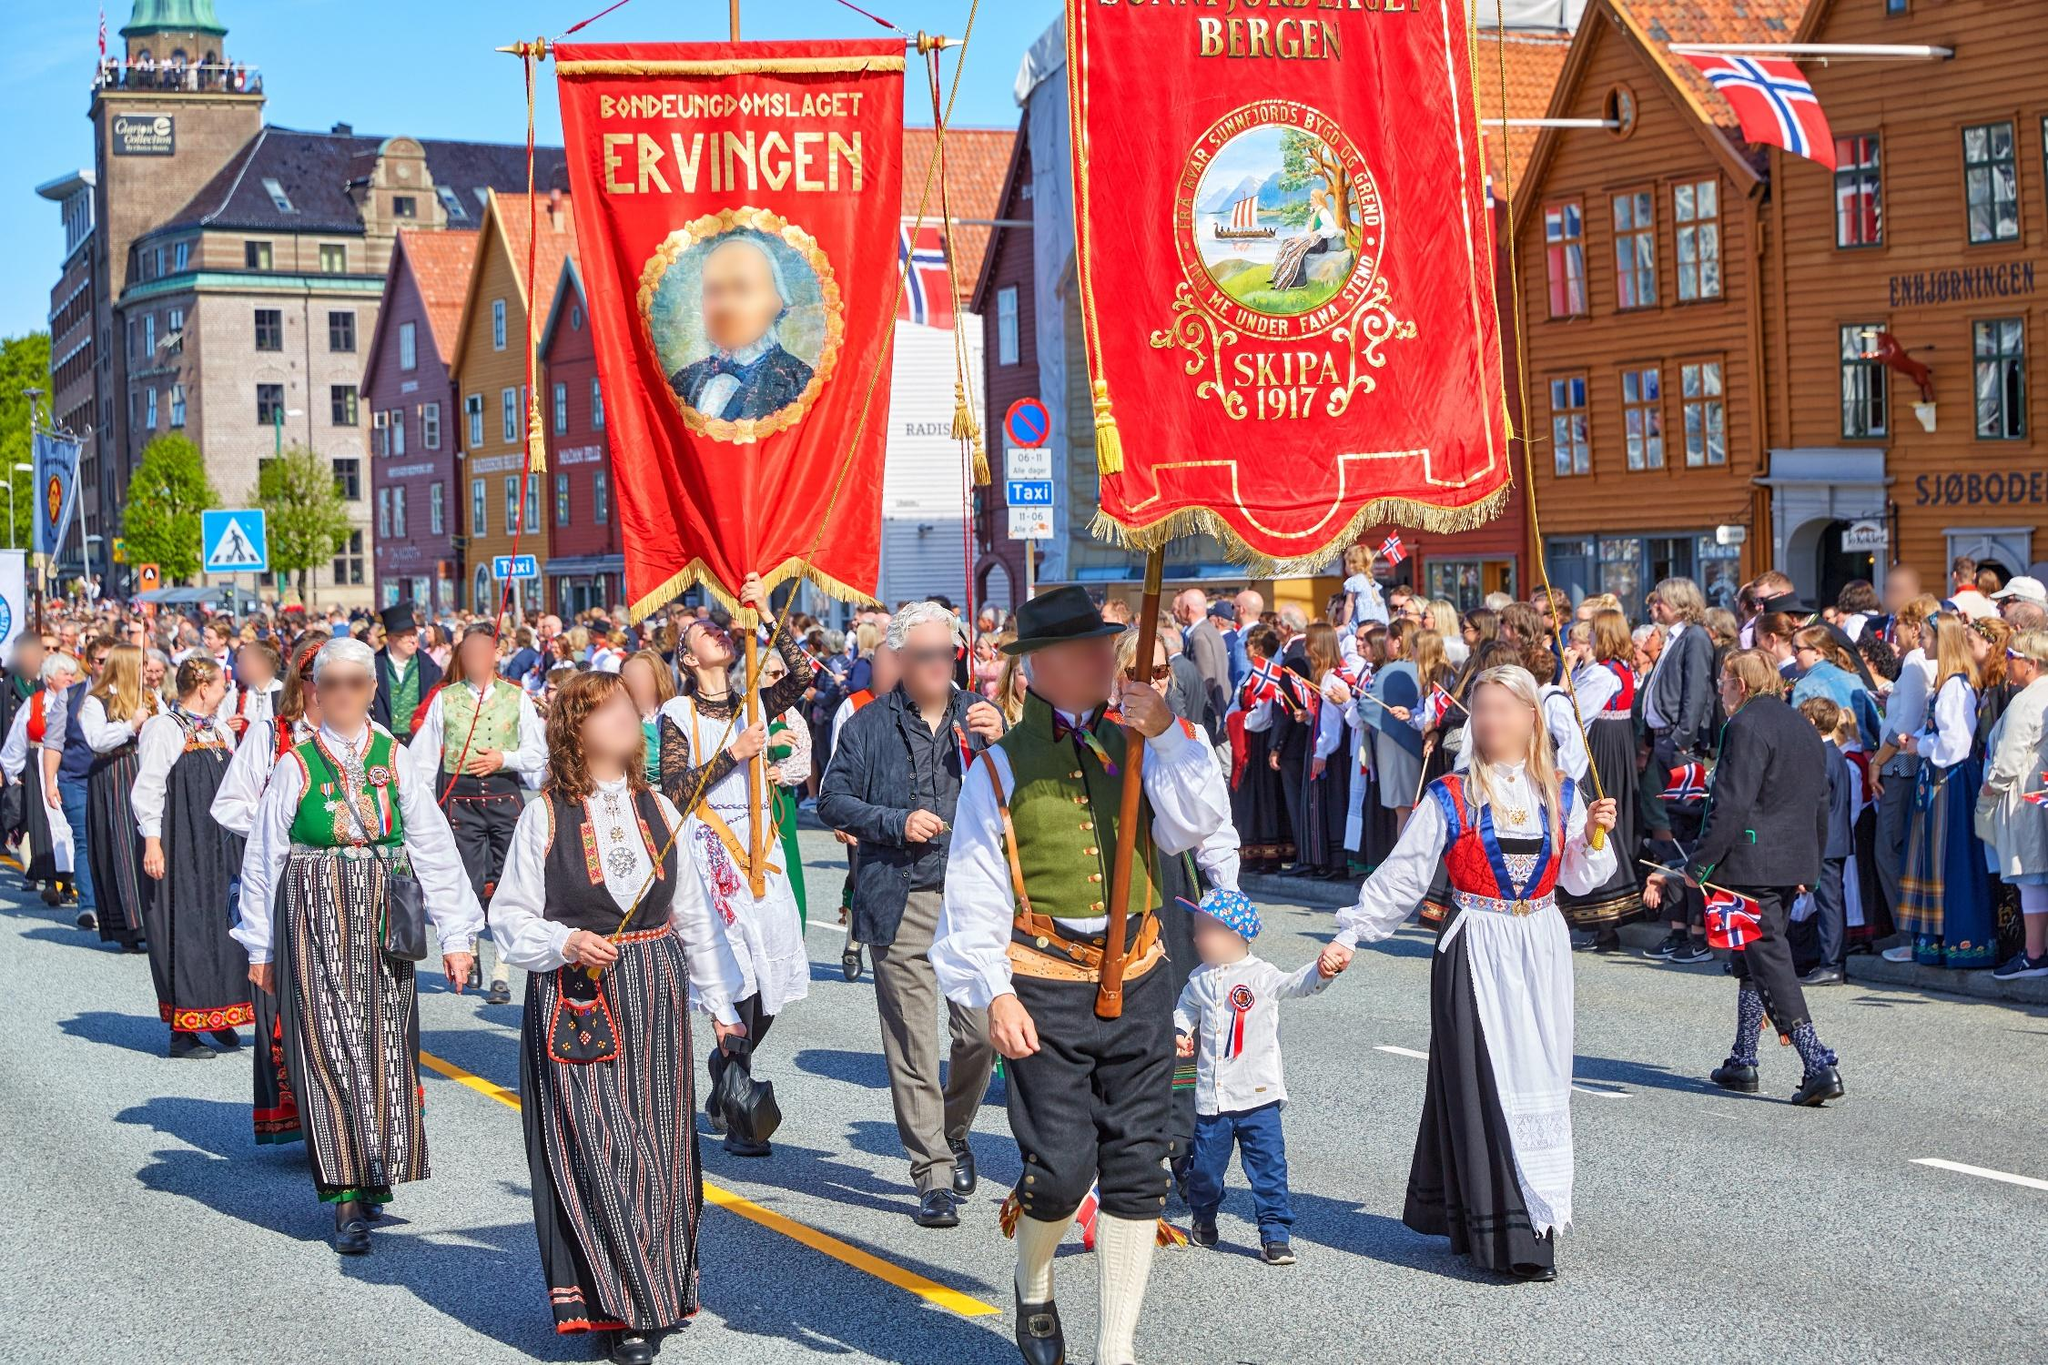Analyze the image in a comprehensive and detailed manner. The image depicts a lively and colorful parade occurring in what appears to be a Scandinavian city, specifically Bergen, Norway. The street is flanked by charming, traditional buildings painted in various hues of brown, red, and orange. Participants in the parade are dressed in traditional Norwegian costumes known as bunads, which are rich in detail and color, reflecting the pride in cultural heritage. The crowd is carrying banners; one prominently displays the name 'Bergen' while another reads 'SINPSA 1917'. These banners, adorned in vibrant red and gold tones, add to the festive ambiance. The street is crowded with onlookers, some of whom are waving Norwegian flags, contributing to the communal and nationalistic atmosphere. Above, the sky is a clear and bright blue, further enhancing the vibrancy of the scene. This image captures not only a festive moment but also a deep sense of community and cultural celebration. 